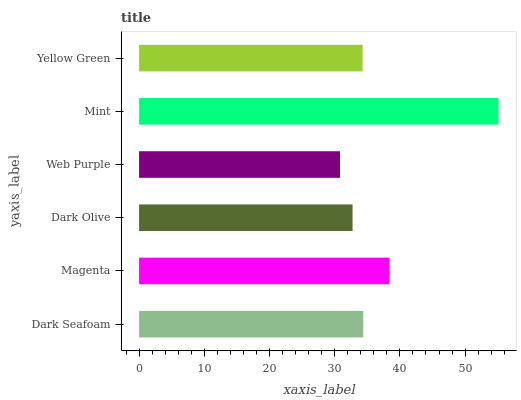Is Web Purple the minimum?
Answer yes or no. Yes. Is Mint the maximum?
Answer yes or no. Yes. Is Magenta the minimum?
Answer yes or no. No. Is Magenta the maximum?
Answer yes or no. No. Is Magenta greater than Dark Seafoam?
Answer yes or no. Yes. Is Dark Seafoam less than Magenta?
Answer yes or no. Yes. Is Dark Seafoam greater than Magenta?
Answer yes or no. No. Is Magenta less than Dark Seafoam?
Answer yes or no. No. Is Dark Seafoam the high median?
Answer yes or no. Yes. Is Yellow Green the low median?
Answer yes or no. Yes. Is Mint the high median?
Answer yes or no. No. Is Web Purple the low median?
Answer yes or no. No. 